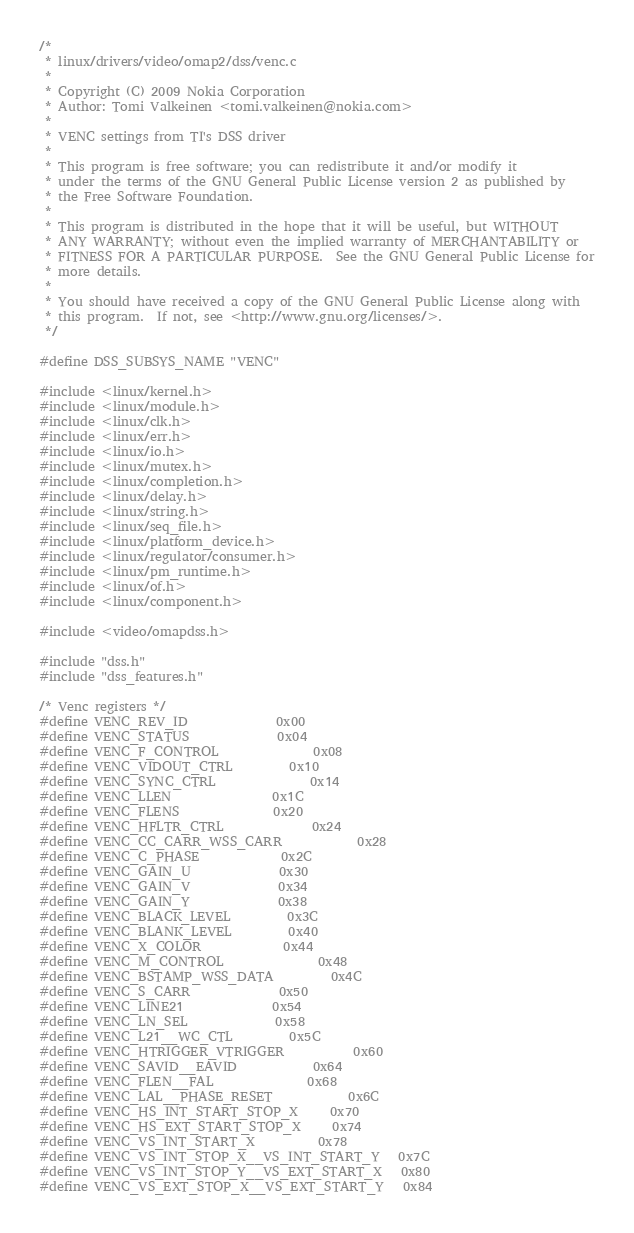Convert code to text. <code><loc_0><loc_0><loc_500><loc_500><_C_>/*
 * linux/drivers/video/omap2/dss/venc.c
 *
 * Copyright (C) 2009 Nokia Corporation
 * Author: Tomi Valkeinen <tomi.valkeinen@nokia.com>
 *
 * VENC settings from TI's DSS driver
 *
 * This program is free software; you can redistribute it and/or modify it
 * under the terms of the GNU General Public License version 2 as published by
 * the Free Software Foundation.
 *
 * This program is distributed in the hope that it will be useful, but WITHOUT
 * ANY WARRANTY; without even the implied warranty of MERCHANTABILITY or
 * FITNESS FOR A PARTICULAR PURPOSE.  See the GNU General Public License for
 * more details.
 *
 * You should have received a copy of the GNU General Public License along with
 * this program.  If not, see <http://www.gnu.org/licenses/>.
 */

#define DSS_SUBSYS_NAME "VENC"

#include <linux/kernel.h>
#include <linux/module.h>
#include <linux/clk.h>
#include <linux/err.h>
#include <linux/io.h>
#include <linux/mutex.h>
#include <linux/completion.h>
#include <linux/delay.h>
#include <linux/string.h>
#include <linux/seq_file.h>
#include <linux/platform_device.h>
#include <linux/regulator/consumer.h>
#include <linux/pm_runtime.h>
#include <linux/of.h>
#include <linux/component.h>

#include <video/omapdss.h>

#include "dss.h"
#include "dss_features.h"

/* Venc registers */
#define VENC_REV_ID				0x00
#define VENC_STATUS				0x04
#define VENC_F_CONTROL				0x08
#define VENC_VIDOUT_CTRL			0x10
#define VENC_SYNC_CTRL				0x14
#define VENC_LLEN				0x1C
#define VENC_FLENS				0x20
#define VENC_HFLTR_CTRL				0x24
#define VENC_CC_CARR_WSS_CARR			0x28
#define VENC_C_PHASE				0x2C
#define VENC_GAIN_U				0x30
#define VENC_GAIN_V				0x34
#define VENC_GAIN_Y				0x38
#define VENC_BLACK_LEVEL			0x3C
#define VENC_BLANK_LEVEL			0x40
#define VENC_X_COLOR				0x44
#define VENC_M_CONTROL				0x48
#define VENC_BSTAMP_WSS_DATA			0x4C
#define VENC_S_CARR				0x50
#define VENC_LINE21				0x54
#define VENC_LN_SEL				0x58
#define VENC_L21__WC_CTL			0x5C
#define VENC_HTRIGGER_VTRIGGER			0x60
#define VENC_SAVID__EAVID			0x64
#define VENC_FLEN__FAL				0x68
#define VENC_LAL__PHASE_RESET			0x6C
#define VENC_HS_INT_START_STOP_X		0x70
#define VENC_HS_EXT_START_STOP_X		0x74
#define VENC_VS_INT_START_X			0x78
#define VENC_VS_INT_STOP_X__VS_INT_START_Y	0x7C
#define VENC_VS_INT_STOP_Y__VS_EXT_START_X	0x80
#define VENC_VS_EXT_STOP_X__VS_EXT_START_Y	0x84</code> 